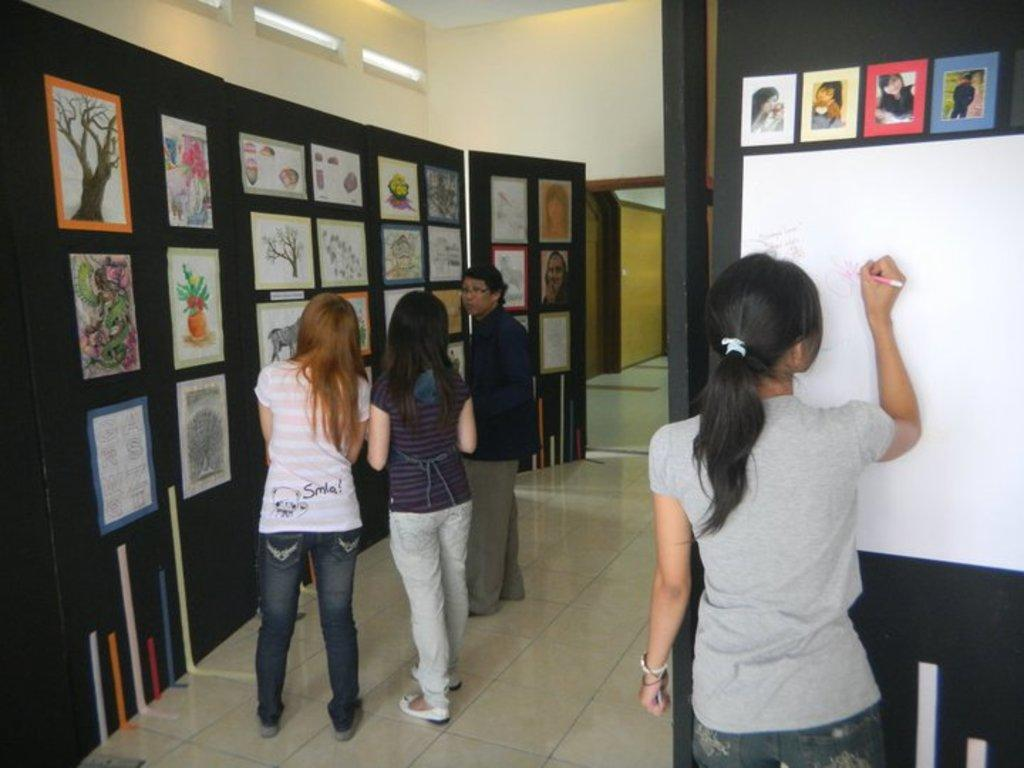What type of structure can be seen in the image? There is a wall in the image. What can be seen illuminating the area in the image? There are lights in the image. What type of objects are present on the wall in the image? There are papers and a drawing in the image. Are there any people visible in the image? Yes, there are people present in the image. What type of company does the aunt own, and how does it relate to the image? There is no mention of a company or an aunt in the image, so it is not possible to answer that question. 